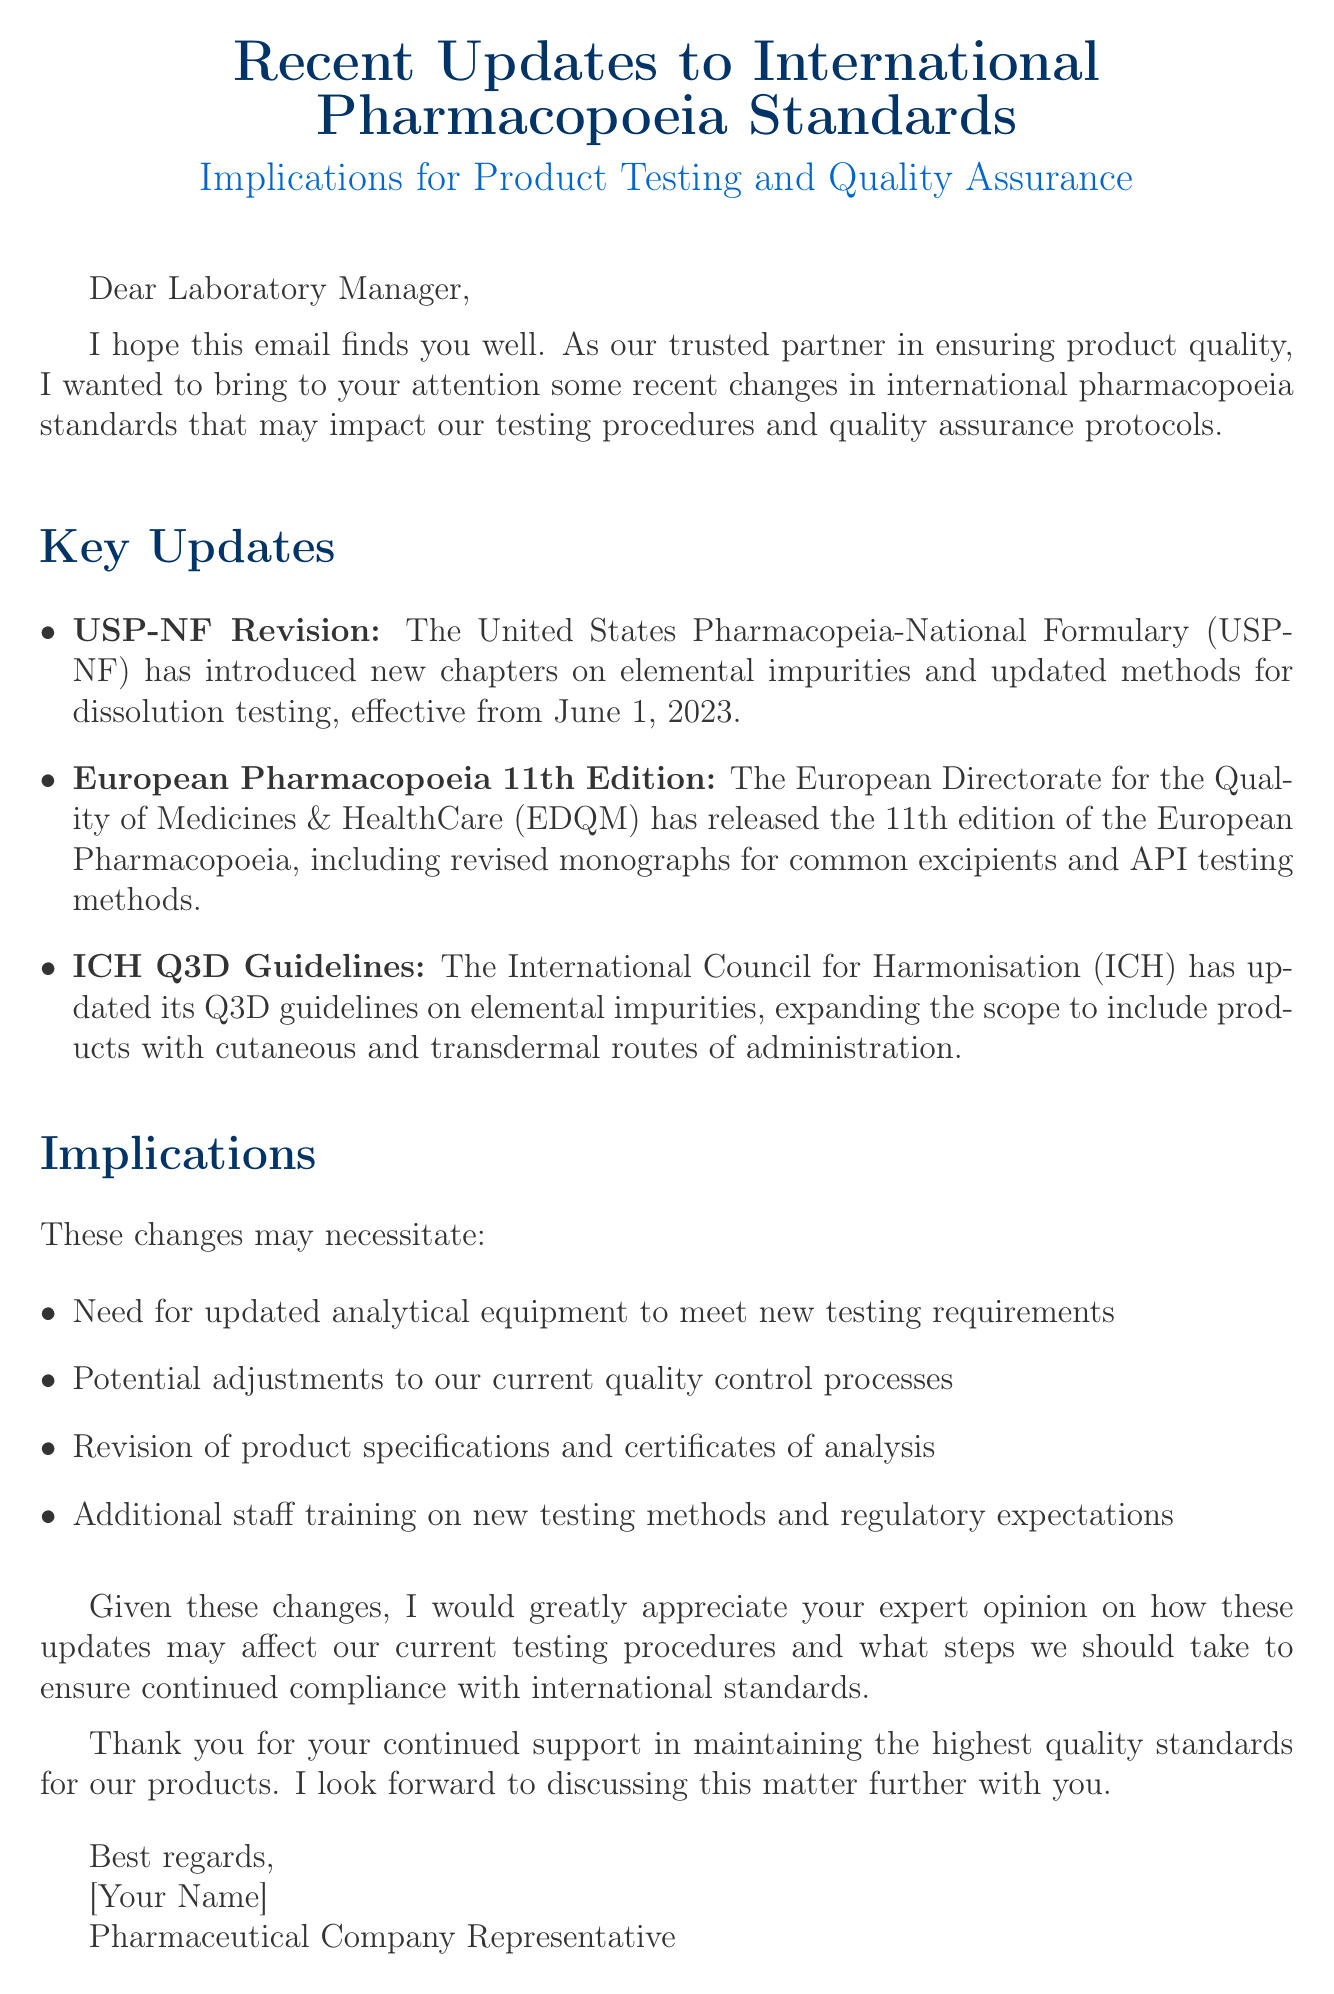what is the subject of the email? The subject of the email is a specific phrase that introduces the content, which is "Recent Updates to International Pharmacopoeia Standards: Implications for Product Testing and Quality Assurance."
Answer: Recent Updates to International Pharmacopoeia Standards: Implications for Product Testing and Quality Assurance when did the USP-NF updates become effective? The document states a specific date when the updates were effective, which is June 1, 2023.
Answer: June 1, 2023 which organization released the European Pharmacopoeia 11th Edition? The email refers to the specific organization that released the edition, which is the European Directorate for the Quality of Medicines & HealthCare.
Answer: European Directorate for the Quality of Medicines & HealthCare what is one implication of the recent changes mentioned? An implication is a specific consequence resulting from the changes mentioned in the document, such as the need for updated analytical equipment.
Answer: Need for updated analytical equipment what are the new guidelines introduced by ICH? This question asks for the specific name of the guidelines referred to in the email, which are related to elemental impurities.
Answer: Q3D guidelines what is being requested from the laboratory manager? The request in the email outlines a desire for professional insight regarding a particular topic, which is the expert opinion on the updates' effects.
Answer: Expert opinion on how these updates may affect our current testing procedures who is the sender of the email? The email concludes with a signature that identifies the individual sending the communication, which states "Pharmaceutical Company Representative."
Answer: Pharmaceutical Company Representative how are the changes expected to affect staff training? This question focuses on a specific aspect of the implications concerning operational changes, indicating a requirement for adjustments in personnel training.
Answer: Additional staff training on new testing methods and regulatory expectations 